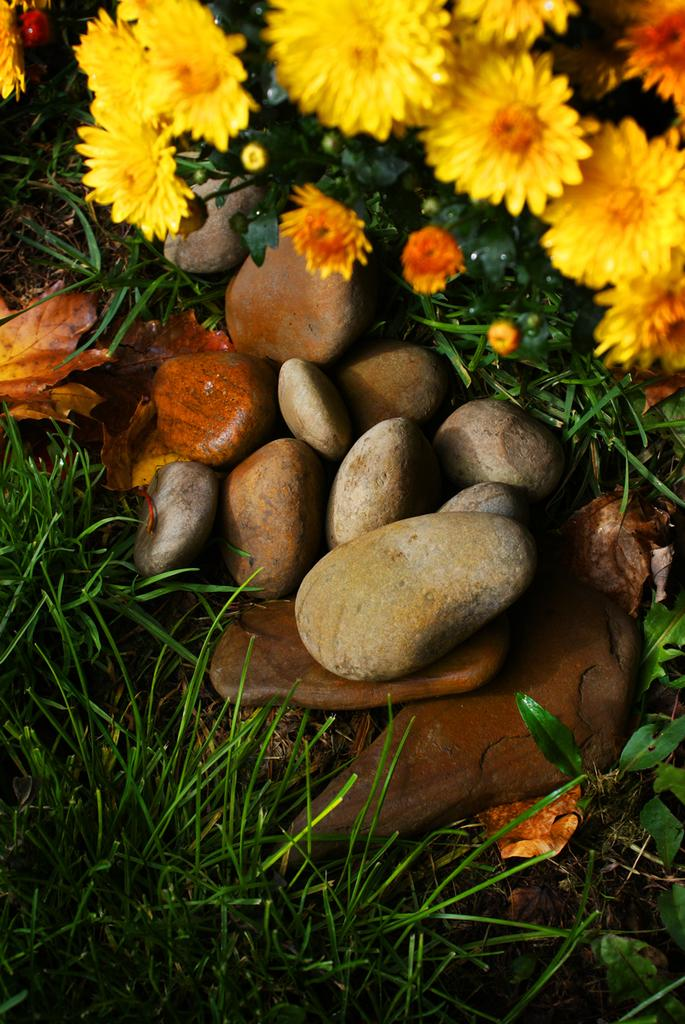What type of vegetation can be seen in the image? There are plants and flowers in the image. What other elements are present in the image besides vegetation? There are stones and dried leaves on the surface at the bottom of the image. What type of ground cover is visible at the bottom of the image? There is grass at the bottom of the image. What type of account is being discussed in the image? There is no account being discussed in the image; it features plants, flowers, stones, grass, and dried leaves. 